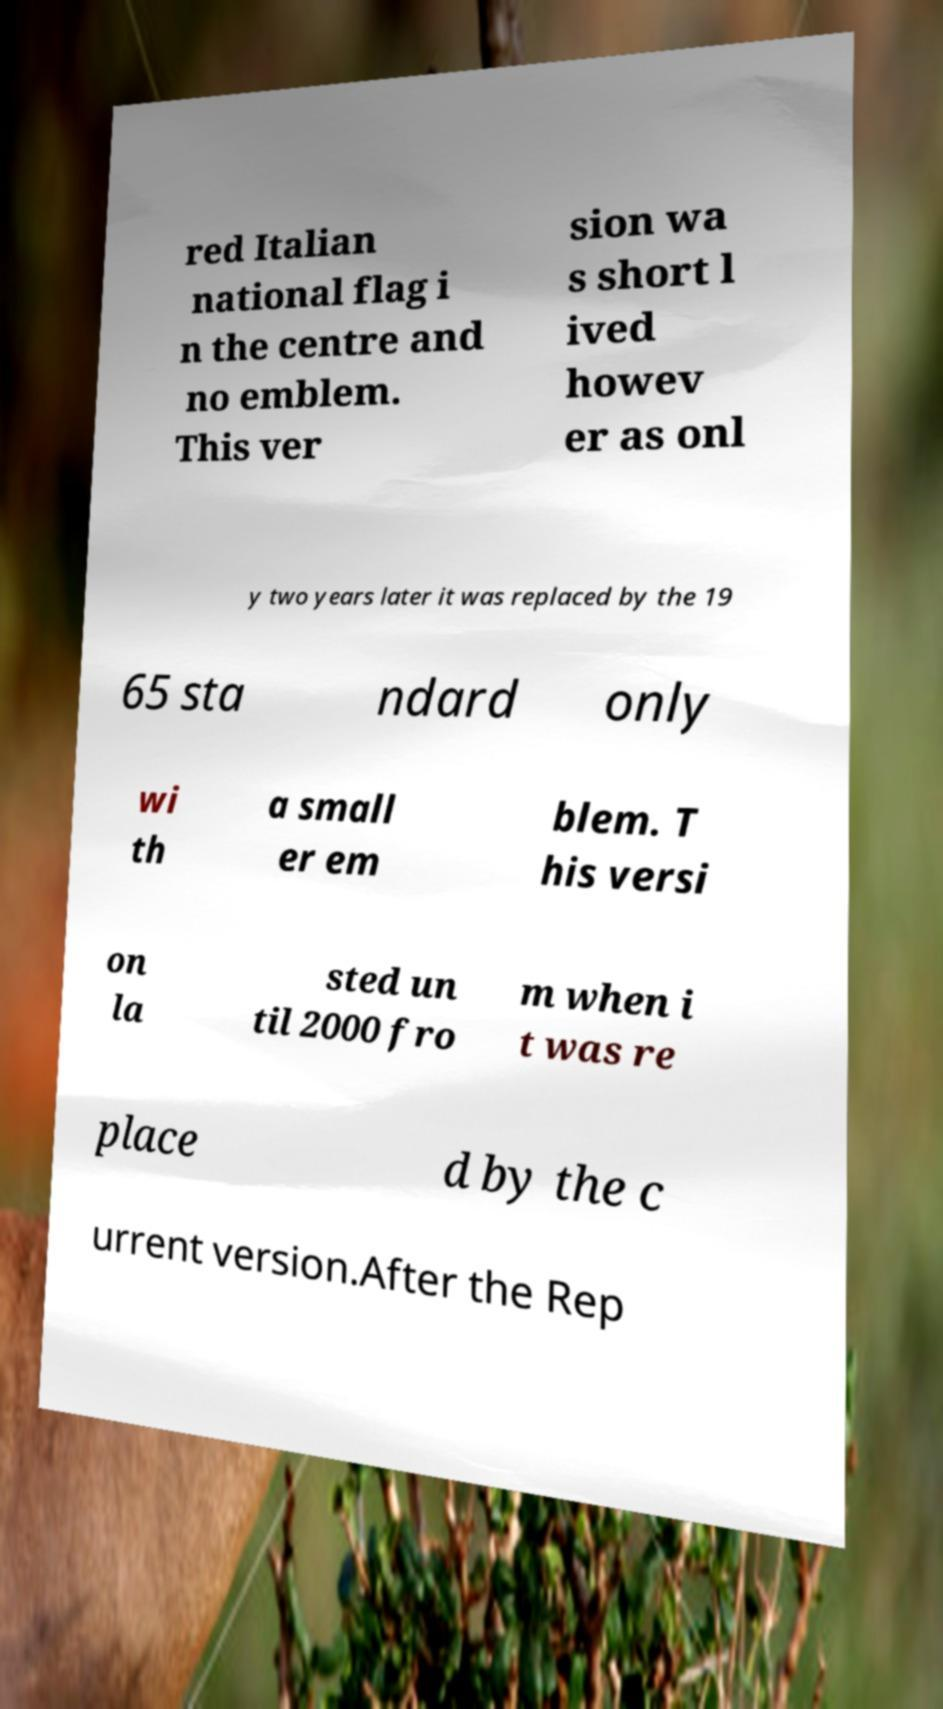What messages or text are displayed in this image? I need them in a readable, typed format. red Italian national flag i n the centre and no emblem. This ver sion wa s short l ived howev er as onl y two years later it was replaced by the 19 65 sta ndard only wi th a small er em blem. T his versi on la sted un til 2000 fro m when i t was re place d by the c urrent version.After the Rep 